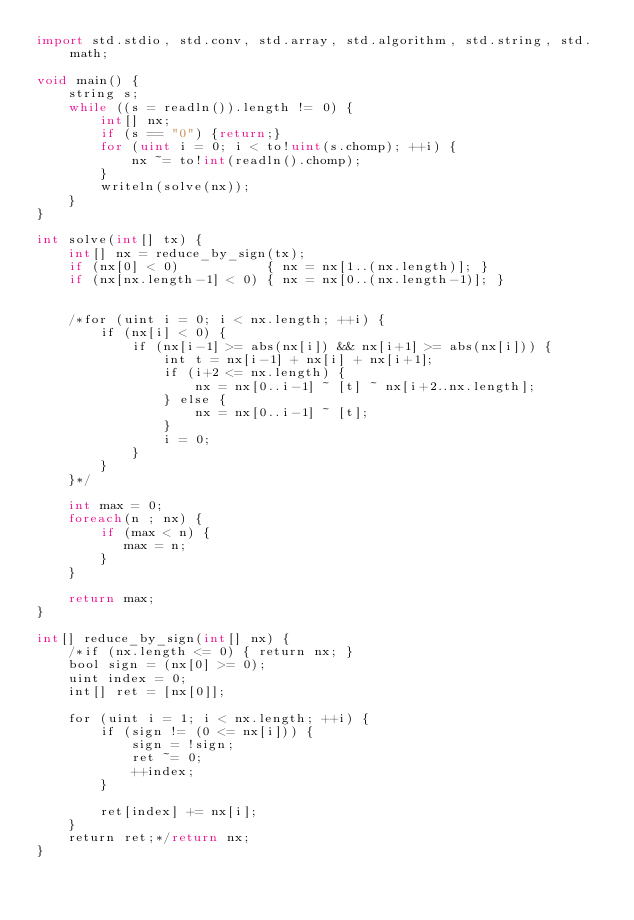Convert code to text. <code><loc_0><loc_0><loc_500><loc_500><_D_>import std.stdio, std.conv, std.array, std.algorithm, std.string, std.math;

void main() {
    string s;
    while ((s = readln()).length != 0) {
        int[] nx;
        if (s == "0") {return;}
        for (uint i = 0; i < to!uint(s.chomp); ++i) {
            nx ~= to!int(readln().chomp);   
        }
        writeln(solve(nx));
    }
}

int solve(int[] tx) {
    int[] nx = reduce_by_sign(tx);
    if (nx[0] < 0)           { nx = nx[1..(nx.length)]; }
    if (nx[nx.length-1] < 0) { nx = nx[0..(nx.length-1)]; }


    /*for (uint i = 0; i < nx.length; ++i) {
        if (nx[i] < 0) {
            if (nx[i-1] >= abs(nx[i]) && nx[i+1] >= abs(nx[i])) {
                int t = nx[i-1] + nx[i] + nx[i+1];
                if (i+2 <= nx.length) {
                    nx = nx[0..i-1] ~ [t] ~ nx[i+2..nx.length];
                } else {
                    nx = nx[0..i-1] ~ [t];
                }
                i = 0;
            }
        }
    }*/

    int max = 0;
    foreach(n ; nx) {
        if (max < n) {
           max = n;   
        }
    }
    
    return max;
}

int[] reduce_by_sign(int[] nx) {
    /*if (nx.length <= 0) { return nx; }
    bool sign = (nx[0] >= 0);
    uint index = 0;
    int[] ret = [nx[0]];
    
    for (uint i = 1; i < nx.length; ++i) {
        if (sign != (0 <= nx[i])) {
            sign = !sign;
            ret ~= 0;
            ++index;
        }
            
        ret[index] += nx[i];
    }
    return ret;*/return nx;
}</code> 